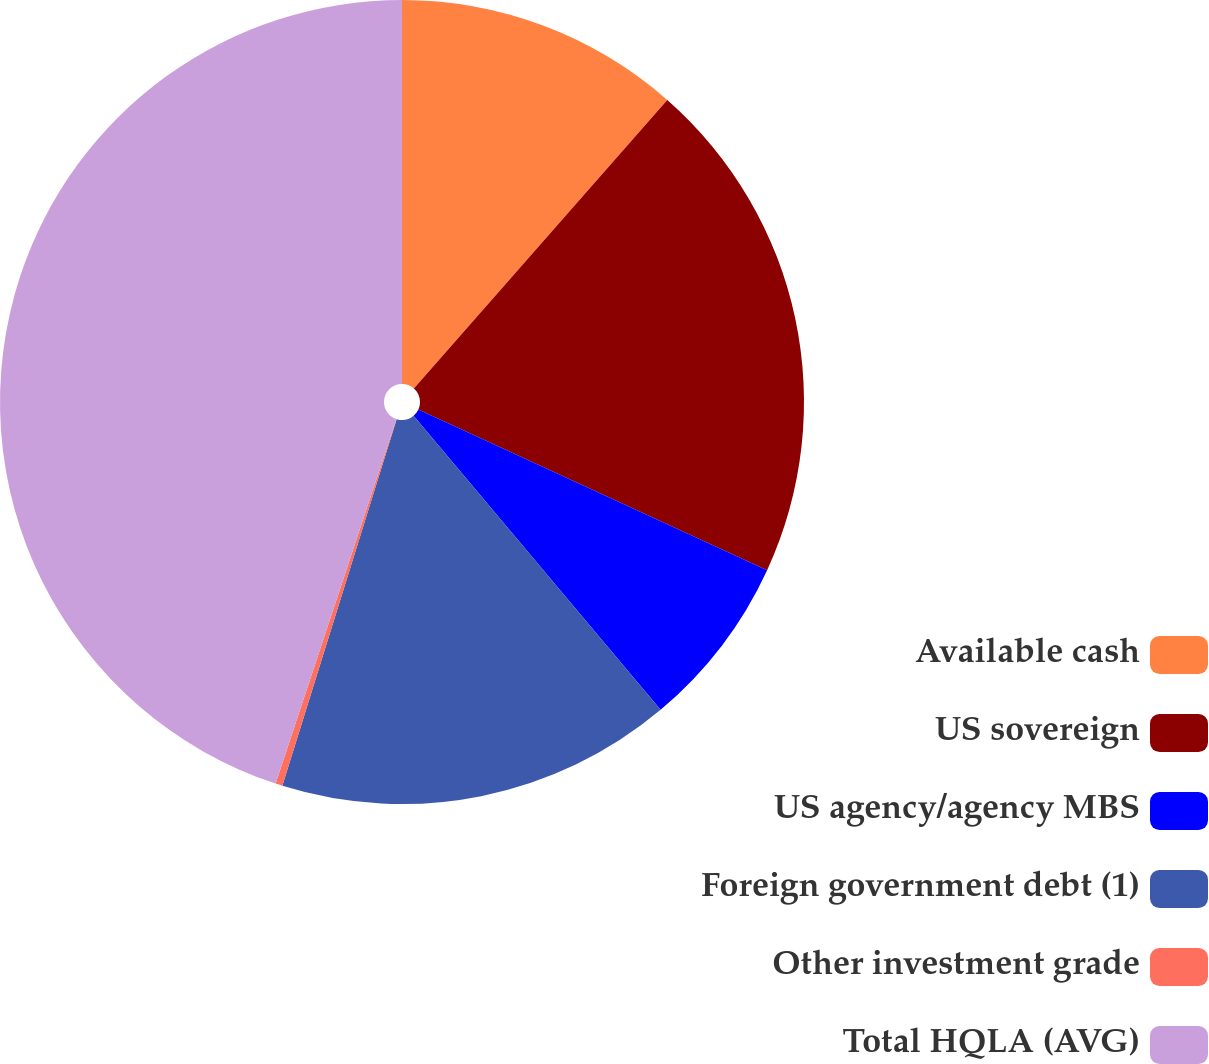<chart> <loc_0><loc_0><loc_500><loc_500><pie_chart><fcel>Available cash<fcel>US sovereign<fcel>US agency/agency MBS<fcel>Foreign government debt (1)<fcel>Other investment grade<fcel>Total HQLA (AVG)<nl><fcel>11.47%<fcel>20.4%<fcel>7.01%<fcel>15.93%<fcel>0.28%<fcel>44.91%<nl></chart> 